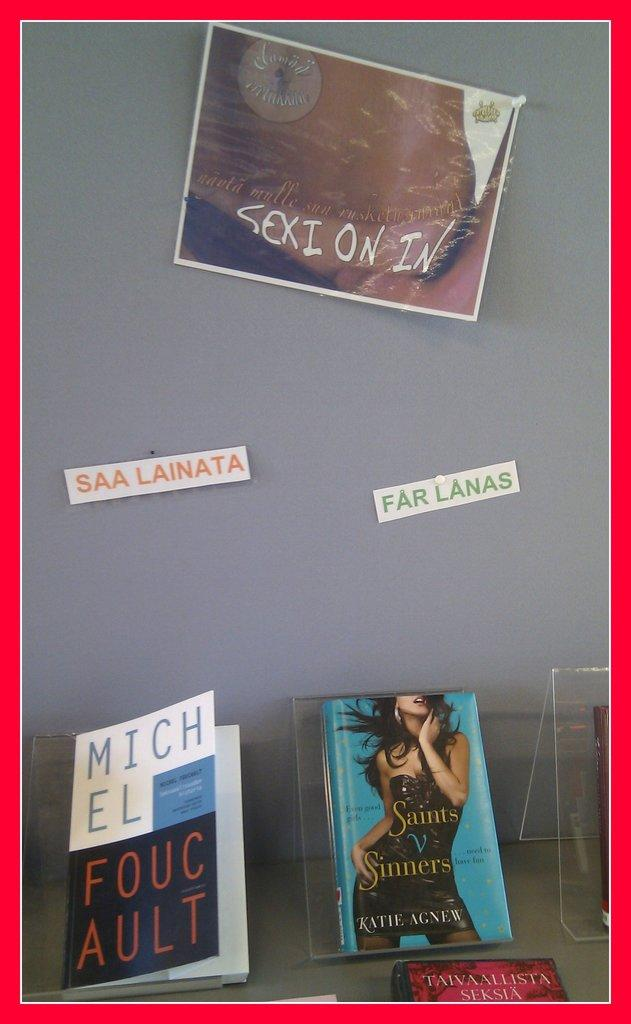<image>
Present a compact description of the photo's key features. Saints V Sinners and other Spanish books displayed 